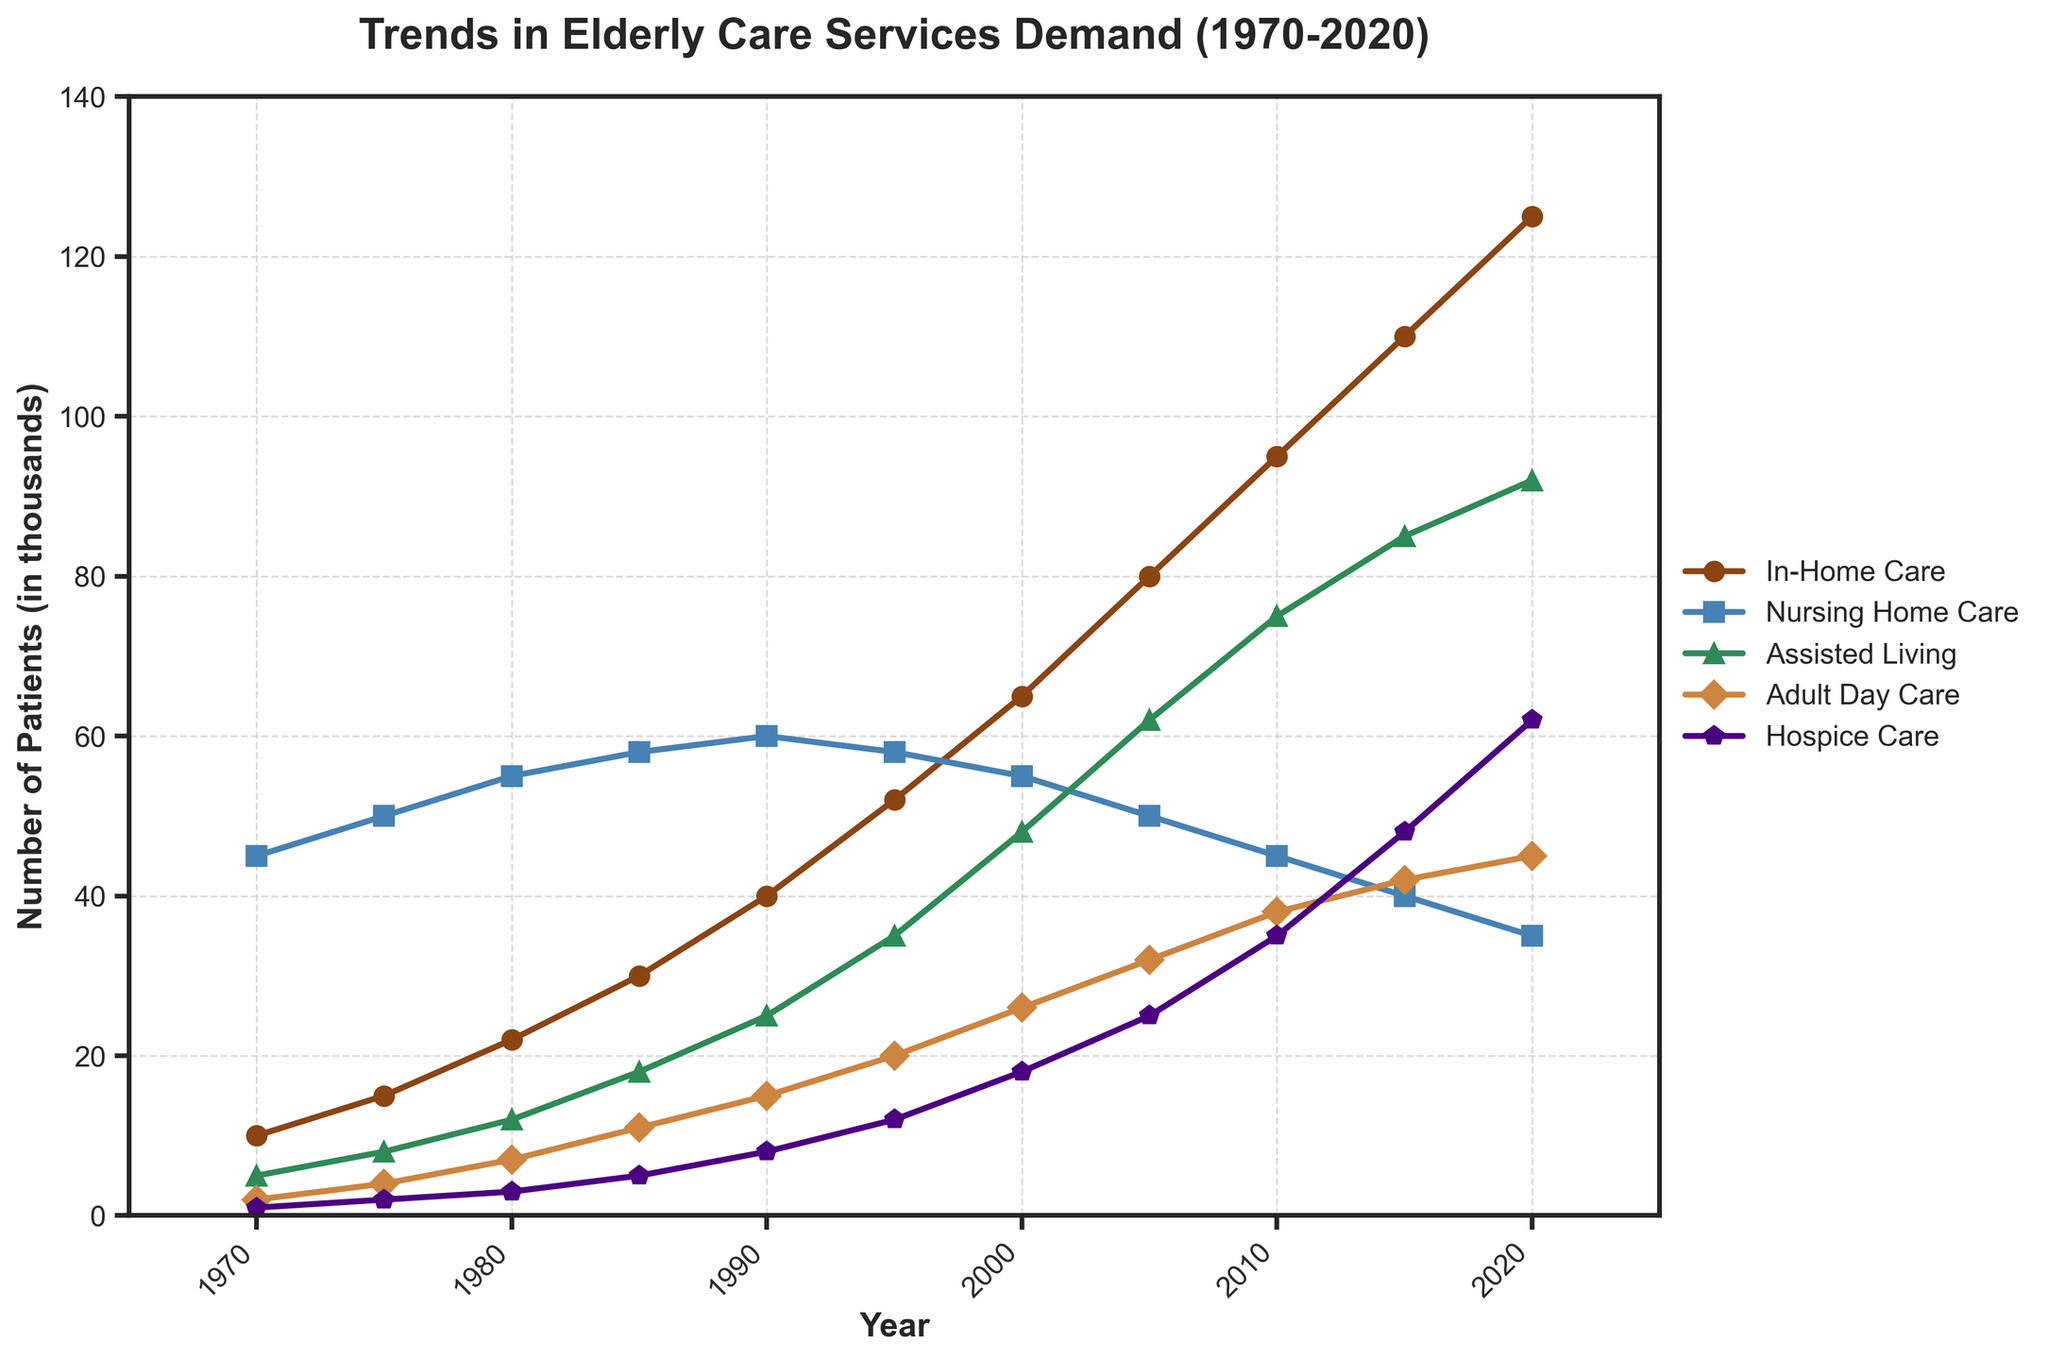What's the general trend in demand for Nursing Home Care from 1970 to 2020? The figure shows that the demand for Nursing Home Care has generally declined over the years, starting at 45 in 1970 and dropping to 35 in 2020.
Answer: Decreasing Which type of care saw the highest increase in demand from 1970 to 2020? By looking at the start and end point for each type of care, In-Home Care increased the most—starting from 10 in 1970 to 125 in 2020, an increase of 115 units.
Answer: In-Home Care What was the demand for Adult Day Care in 2000, and how does it compare to the demand in 2020? The demand for Adult Day Care in 2000 was 26. By 2020, it had risen to 45.
Answer: 26 in 2000, 45 in 2020 Which service had the least demand in the year 1970 and what was its value? Examining the values for each type of care in 1970, Hospice Care had the least demand, with a value of 1.
Answer: Hospice Care, 1 How does the demand for Assisted Living in 1995 compare to that in 2005? The demand for Assisted Living in 1995 was 35, and in 2005, it increased to 62.
Answer: 35 in 1995, 62 in 2005 In which year did In-Home Care surpass Nursing Home Care demand? By tracing the lines representing In-Home Care and Nursing Home Care, In-Home Care surpassed Nursing Home Care around 1995.
Answer: 1995 What is the difference in demand between Assisted Living and Hospice Care in 2015? The demand for Assisted Living in 2015 was 85, and Hospice Care was 48, making the difference 37.
Answer: 37 Between 1990 and 2000, which type of care experienced the highest growth in demand? By comparing the starting and ending values for each type of care between 1990 and 2000, In-Home Care had the highest growth, increasing from 40 to 65.
Answer: In-Home Care What is the general trend in the demand for Hospice Care between 1970 and 2020? The figure shows that Hospice Care demand has increased steadily, starting at 1 in 1970 and reaching 62 in 2020.
Answer: Increasing How does the demand for In-Home Care in 1980 compare to the demand for Nursing Home Care in 1990? The demand for In-Home Care in 1980 was 22, whereas Nursing Home Care in 1990 was 60.
Answer: 22 for In-Home Care in 1980, 60 for Nursing Home Care in 1990 